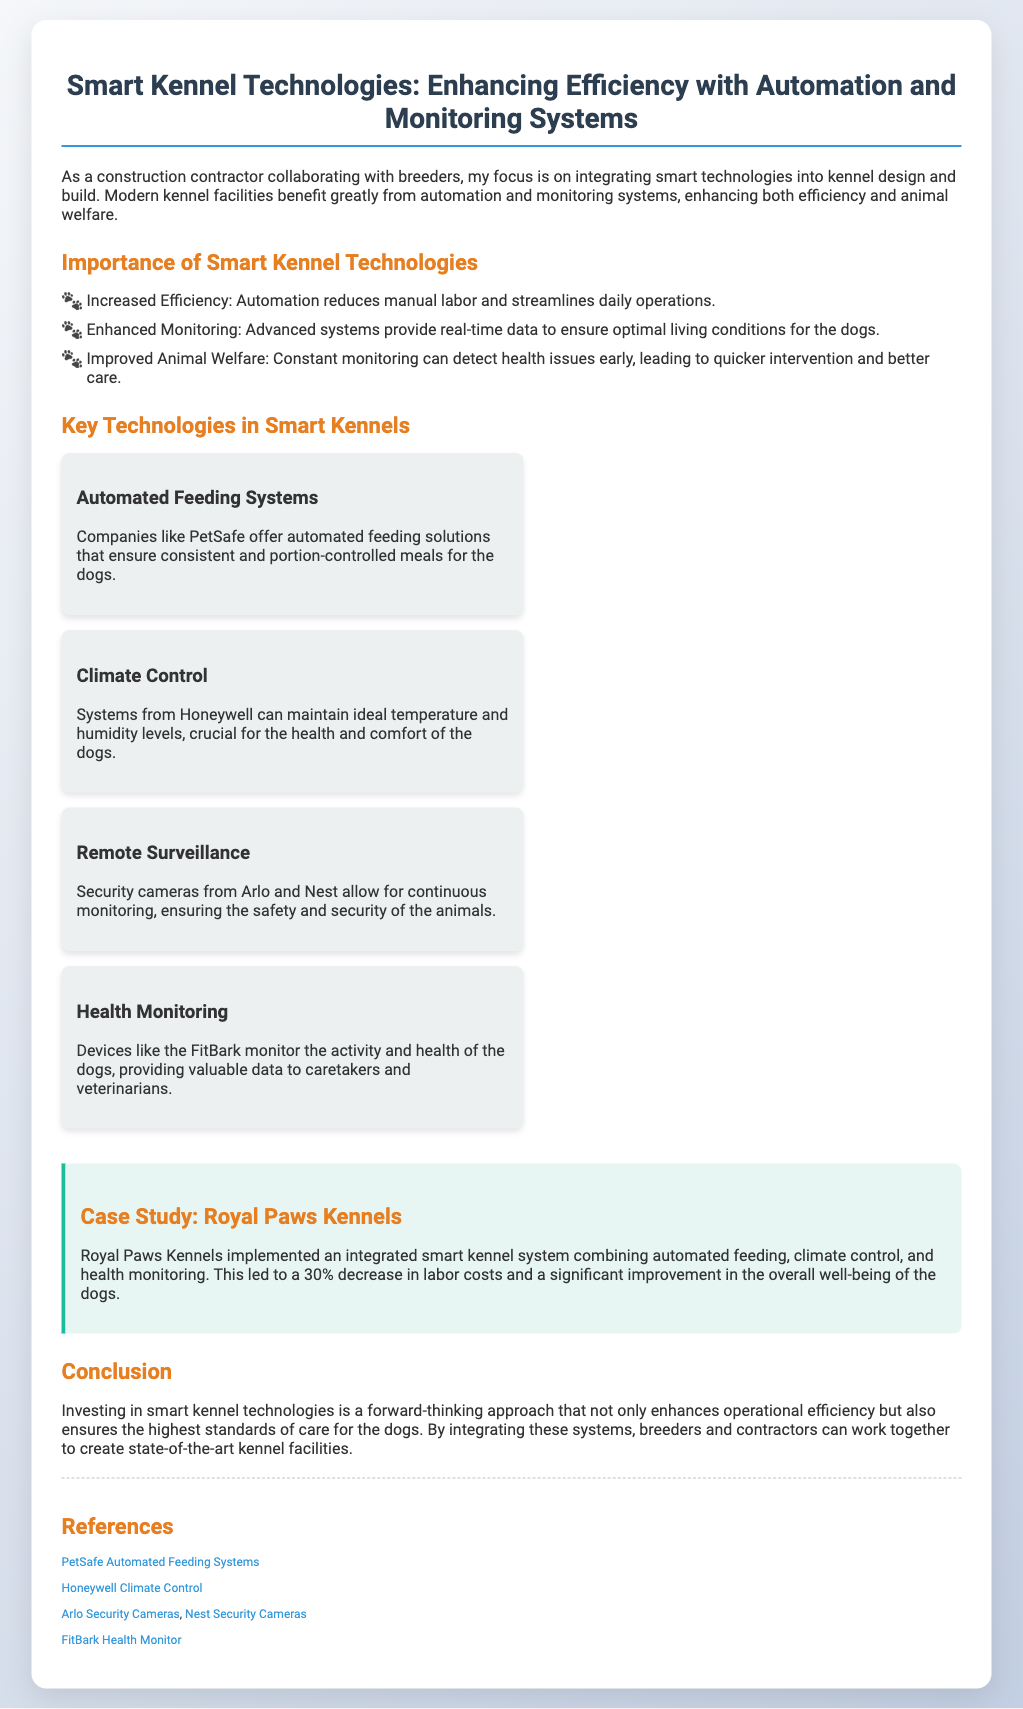What is the title of the presentation? The title is stated at the top of the slide, emphasizing the key theme of the content presented.
Answer: Smart Kennel Technologies: Enhancing Efficiency with Automation and Monitoring Systems What technology is used for automated feeding? The document mentions specific companies providing automated feeding solutions for kennels.
Answer: PetSafe What percentage decrease in labor costs did Royal Paws Kennels achieve? The case study provides a specific statistic related to the efficiency gains from implementing the technologies.
Answer: 30% Which company provides climate control systems? The document lists a specific company known for climate control technology in smart kennels.
Answer: Honeywell What is the main benefit of health monitoring devices according to the document? The document outlines the primary purpose of health monitoring devices used in kennels.
Answer: Valuable data What specific monitoring system allows for continuous animal surveillance? The document highlights specific technologies that aid in surveillance for animal safety and security.
Answer: Security cameras What is one of the key points in the importance of smart kennel technologies? The document lists several important aspects regarding the implementation of smart technologies in kennels.
Answer: Increased Efficiency What color is used for the headers in the Document? The document visually describes the color scheme used for different text elements.
Answer: Orange 